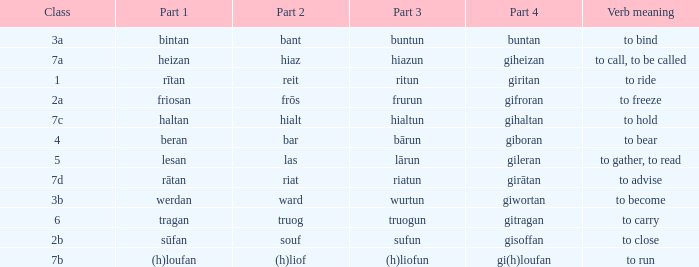What is the part 3 of the word in class 7a? Hiazun. 